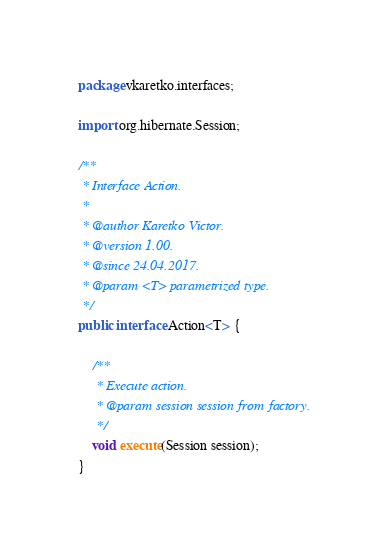<code> <loc_0><loc_0><loc_500><loc_500><_Java_>package vkaretko.interfaces;

import org.hibernate.Session;

/**
 * Interface Action.
 *
 * @author Karetko Victor.
 * @version 1.00.
 * @since 24.04.2017.
 * @param <T> parametrized type.
 */
public interface Action<T> {

    /**
     * Execute action.
     * @param session session from factory.
     */
    void execute(Session session);
}
</code> 